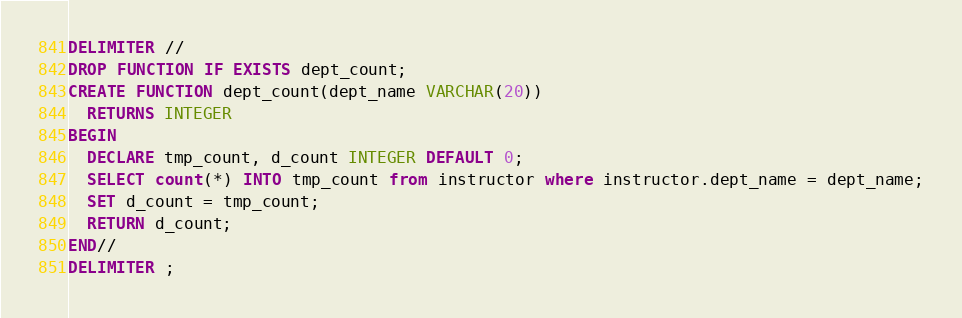Convert code to text. <code><loc_0><loc_0><loc_500><loc_500><_SQL_>DELIMITER //
DROP FUNCTION IF EXISTS dept_count;
CREATE FUNCTION dept_count(dept_name VARCHAR(20))
  RETURNS INTEGER
BEGIN
  DECLARE tmp_count, d_count INTEGER DEFAULT 0;
  SELECT count(*) INTO tmp_count from instructor where instructor.dept_name = dept_name;
  SET d_count = tmp_count;
  RETURN d_count;
END//
DELIMITER ;
</code> 